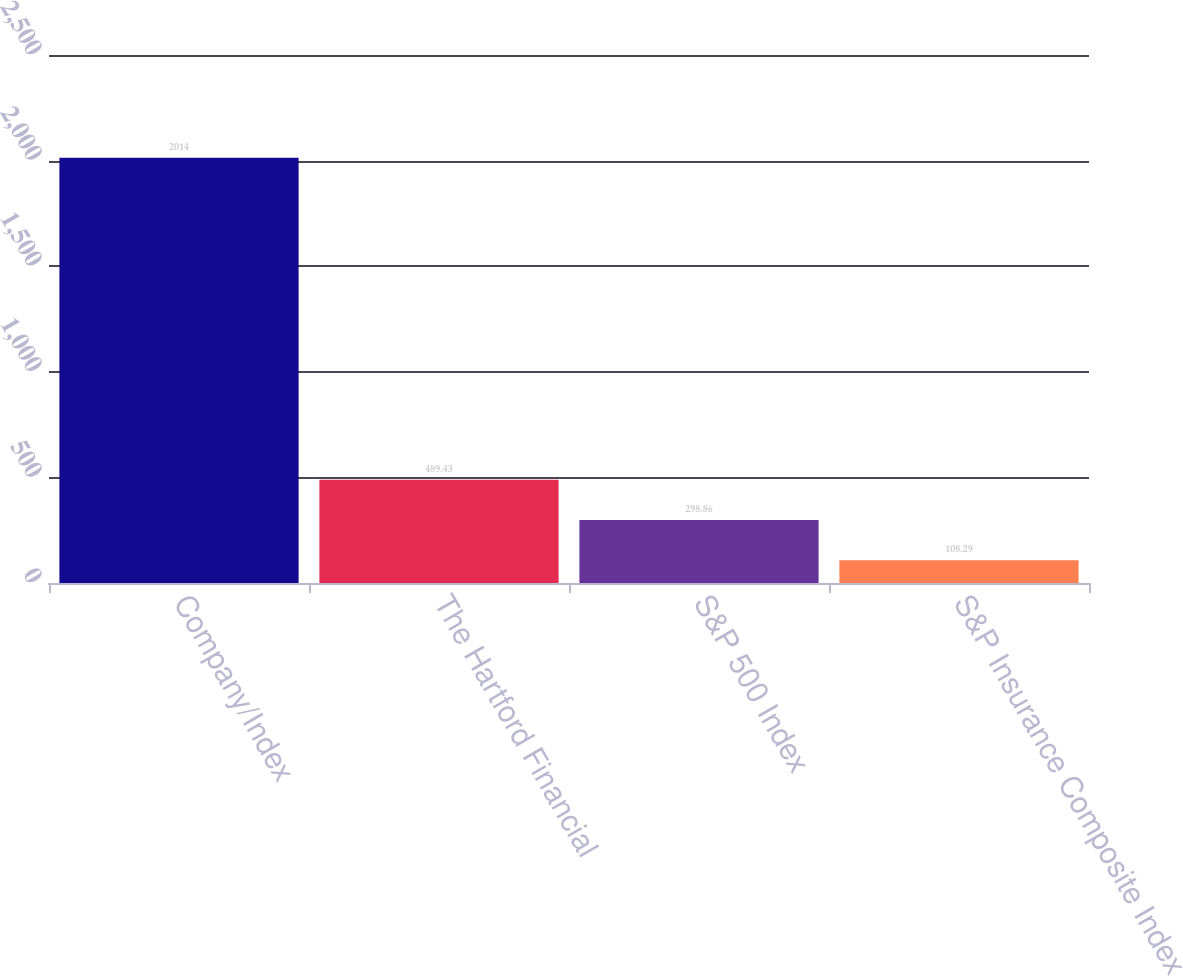Convert chart. <chart><loc_0><loc_0><loc_500><loc_500><bar_chart><fcel>Company/Index<fcel>The Hartford Financial<fcel>S&P 500 Index<fcel>S&P Insurance Composite Index<nl><fcel>2014<fcel>489.43<fcel>298.86<fcel>108.29<nl></chart> 